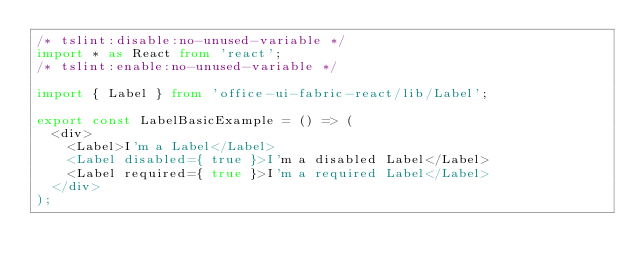Convert code to text. <code><loc_0><loc_0><loc_500><loc_500><_TypeScript_>/* tslint:disable:no-unused-variable */
import * as React from 'react';
/* tslint:enable:no-unused-variable */

import { Label } from 'office-ui-fabric-react/lib/Label';

export const LabelBasicExample = () => (
  <div>
    <Label>I'm a Label</Label>
    <Label disabled={ true }>I'm a disabled Label</Label>
    <Label required={ true }>I'm a required Label</Label>
  </div>
);
</code> 